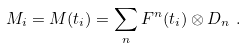Convert formula to latex. <formula><loc_0><loc_0><loc_500><loc_500>M _ { i } & = M ( t _ { i } ) = \sum _ { n } F ^ { n } ( t _ { i } ) \otimes D _ { n } \ .</formula> 